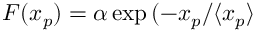Convert formula to latex. <formula><loc_0><loc_0><loc_500><loc_500>F ( x _ { p } ) = \alpha \exp { ( - x _ { p } / \langle x _ { p } \rangle }</formula> 